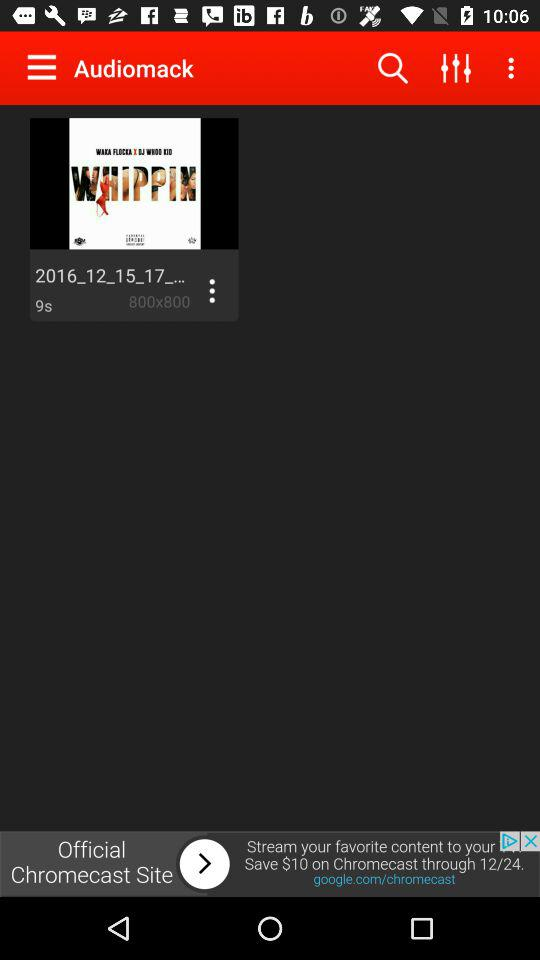Who is the application powered by?
When the provided information is insufficient, respond with <no answer>. <no answer> 